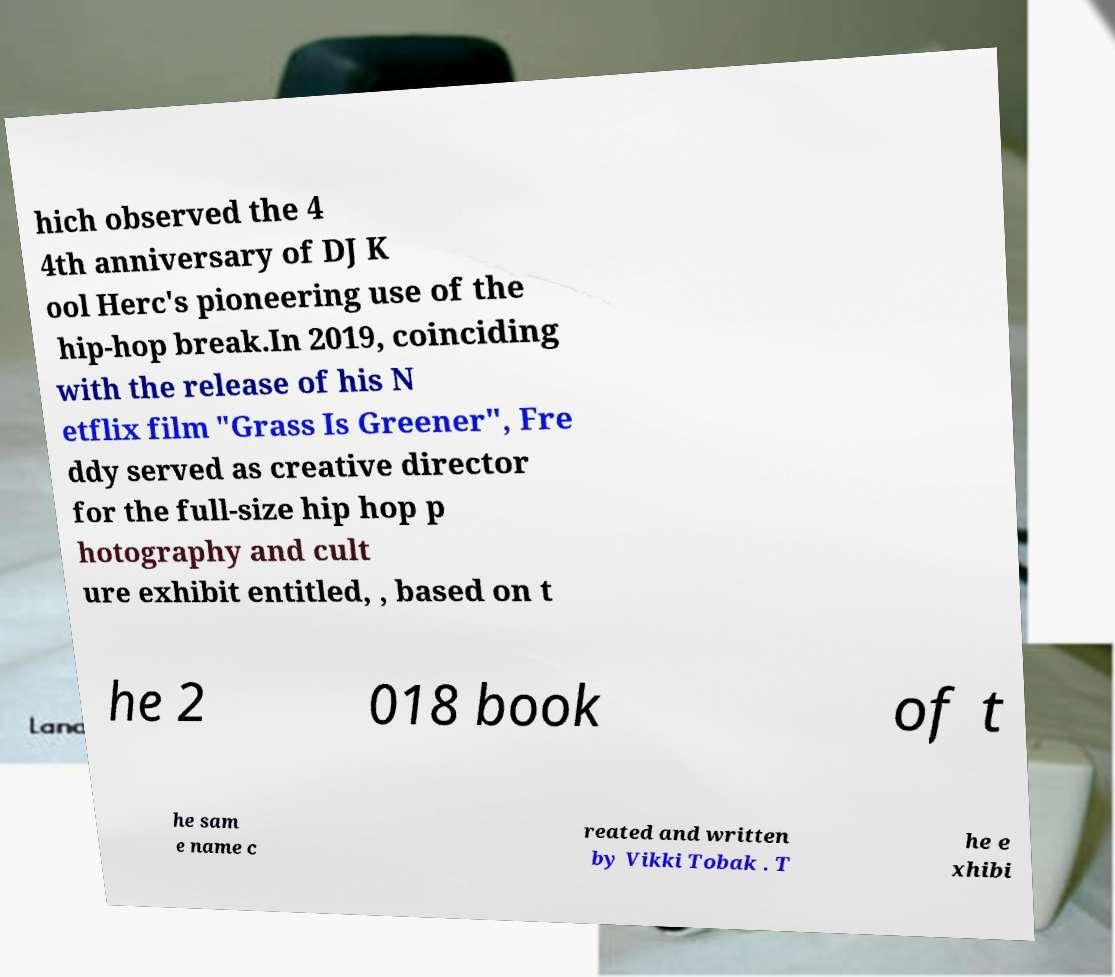Could you assist in decoding the text presented in this image and type it out clearly? hich observed the 4 4th anniversary of DJ K ool Herc's pioneering use of the hip-hop break.In 2019, coinciding with the release of his N etflix film "Grass Is Greener", Fre ddy served as creative director for the full-size hip hop p hotography and cult ure exhibit entitled, , based on t he 2 018 book of t he sam e name c reated and written by Vikki Tobak . T he e xhibi 